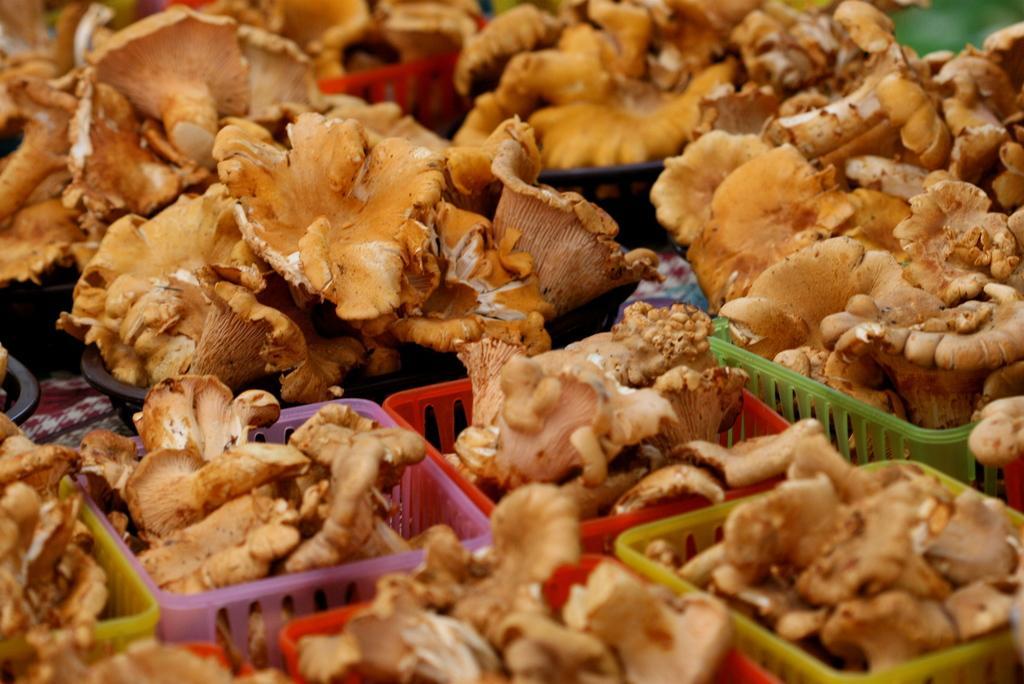Please provide a concise description of this image. In this image I can see vegetables baskets kept on the floor. This image is taken may be in the market. 